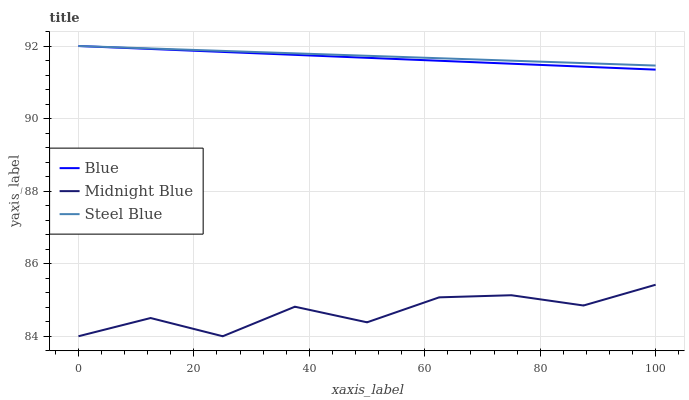Does Midnight Blue have the minimum area under the curve?
Answer yes or no. Yes. Does Steel Blue have the maximum area under the curve?
Answer yes or no. Yes. Does Steel Blue have the minimum area under the curve?
Answer yes or no. No. Does Midnight Blue have the maximum area under the curve?
Answer yes or no. No. Is Blue the smoothest?
Answer yes or no. Yes. Is Midnight Blue the roughest?
Answer yes or no. Yes. Is Steel Blue the smoothest?
Answer yes or no. No. Is Steel Blue the roughest?
Answer yes or no. No. Does Midnight Blue have the lowest value?
Answer yes or no. Yes. Does Steel Blue have the lowest value?
Answer yes or no. No. Does Steel Blue have the highest value?
Answer yes or no. Yes. Does Midnight Blue have the highest value?
Answer yes or no. No. Is Midnight Blue less than Steel Blue?
Answer yes or no. Yes. Is Blue greater than Midnight Blue?
Answer yes or no. Yes. Does Steel Blue intersect Blue?
Answer yes or no. Yes. Is Steel Blue less than Blue?
Answer yes or no. No. Is Steel Blue greater than Blue?
Answer yes or no. No. Does Midnight Blue intersect Steel Blue?
Answer yes or no. No. 